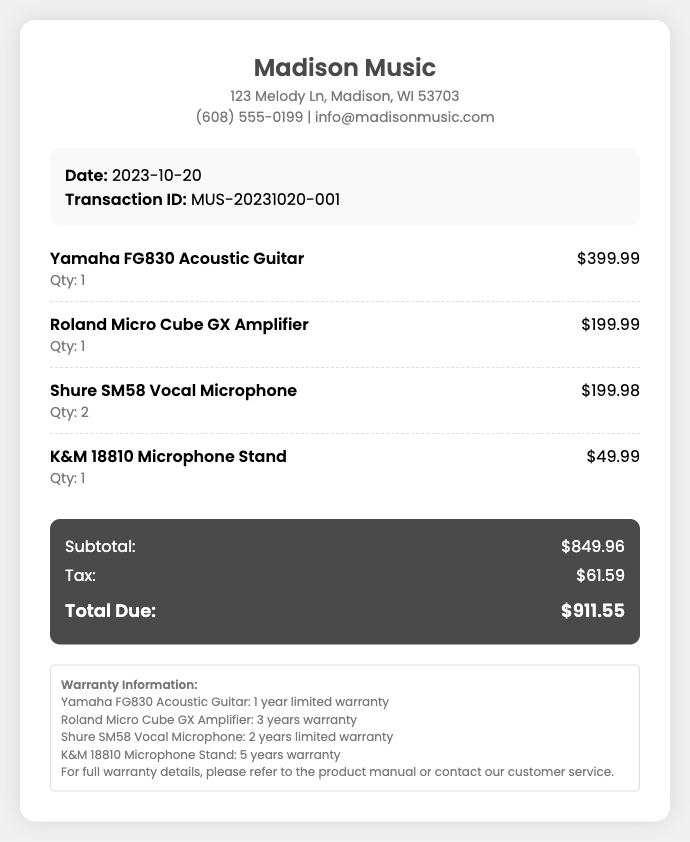What is the transaction date? The date of the transaction is specified in the document as the day when the purchase was made, which is 2023-10-20.
Answer: 2023-10-20 What is the total amount due? The total amount due is calculated from the subtotal and tax in the document. It is clearly stated as $911.55.
Answer: $911.55 How many Shure SM58 Vocal Microphones were purchased? The quantity of Shure SM58 Vocal Microphones is mentioned in the itemized list, which indicates a purchase of 2 units.
Answer: 2 What is the warranty for the K&M 18810 Microphone Stand? The warranty information listed in the document specifies the warranty duration for the microphone stand, which is given as 5 years.
Answer: 5 years What is the subtotal amount before tax? The subtotal is indicated in the totals section of the document, showing the total before tax, which is $849.96.
Answer: $849.96 Who is the store's contact email? The store's contact email is provided in the store information section of the document. It is clearly shown as info@madisonmusic.com.
Answer: info@madisonmusic.com What warranty does the Yamaha FG830 Acoustic Guitar have? The warranty for the Yamaha FG830 Acoustic Guitar is specified in the warranty information section, detailing it as 1 year limited warranty.
Answer: 1 year limited warranty What is the price of the Roland Micro Cube GX Amplifier? The price for the Roland Micro Cube GX Amplifier is itemized in the document, which shows it costs $199.99.
Answer: $199.99 What is the address of the Madison Music store? The store address is included in the store information and is provided as 123 Melody Ln, Madison, WI 53703.
Answer: 123 Melody Ln, Madison, WI 53703 